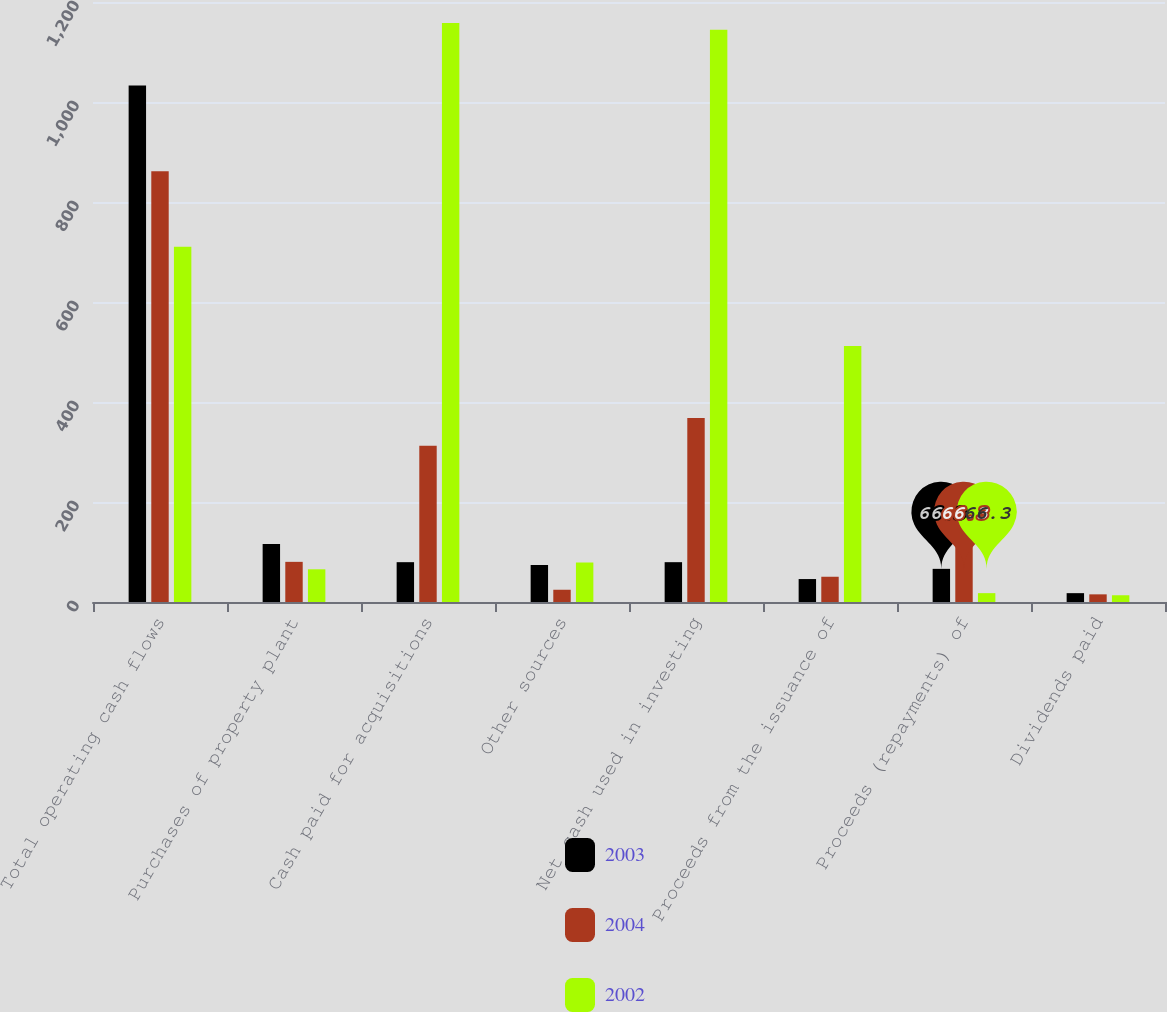Convert chart to OTSL. <chart><loc_0><loc_0><loc_500><loc_500><stacked_bar_chart><ecel><fcel>Total operating cash flows<fcel>Purchases of property plant<fcel>Cash paid for acquisitions<fcel>Other sources<fcel>Net cash used in investing<fcel>Proceeds from the issuance of<fcel>Proceeds (repayments) of<fcel>Dividends paid<nl><fcel>2003<fcel>1033.2<fcel>115.9<fcel>79.65<fcel>74<fcel>79.65<fcel>45.9<fcel>66.3<fcel>17.7<nl><fcel>2004<fcel>861.5<fcel>80.3<fcel>312.3<fcel>24.5<fcel>368.1<fcel>50.5<fcel>145.5<fcel>15.3<nl><fcel>2002<fcel>710.3<fcel>65.4<fcel>1158.1<fcel>79<fcel>1144.5<fcel>512.1<fcel>17.7<fcel>13.5<nl></chart> 